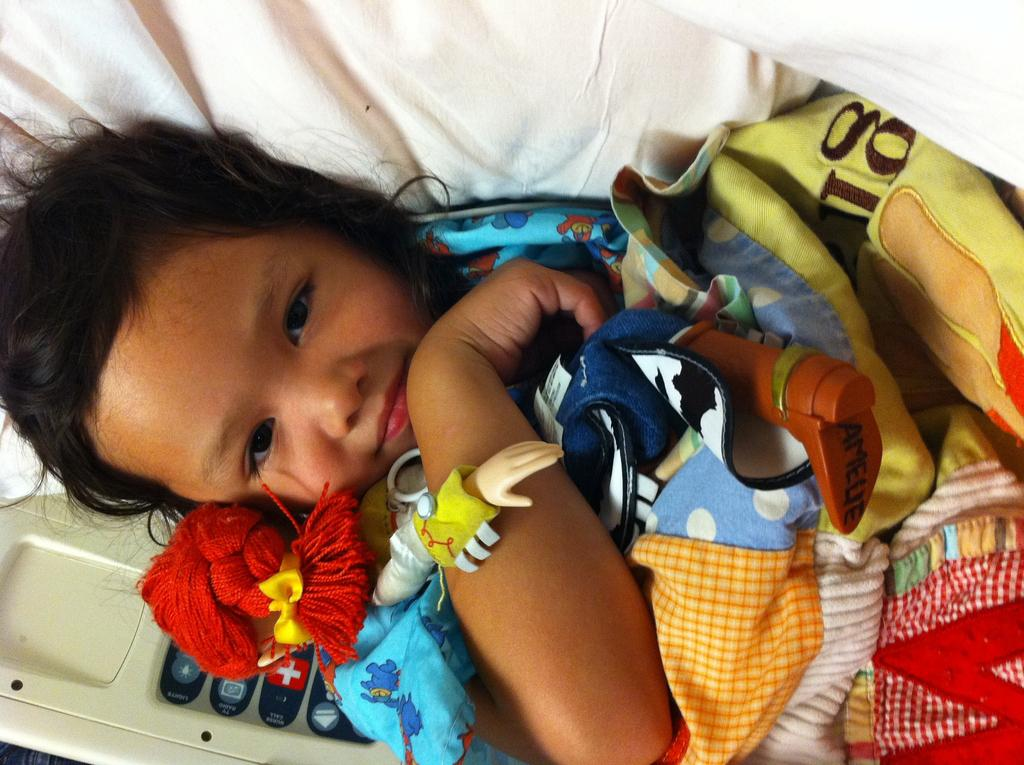<image>
Offer a succinct explanation of the picture presented. A child laying down and holding a doll with the name "Amellie" written on the foot 